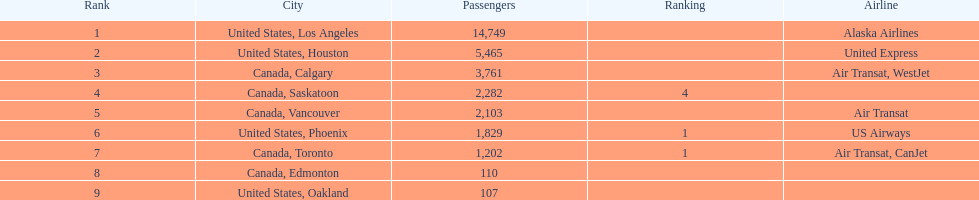How many more passengers flew to los angeles than to saskatoon from manzanillo airport in 2013? 12,467. 